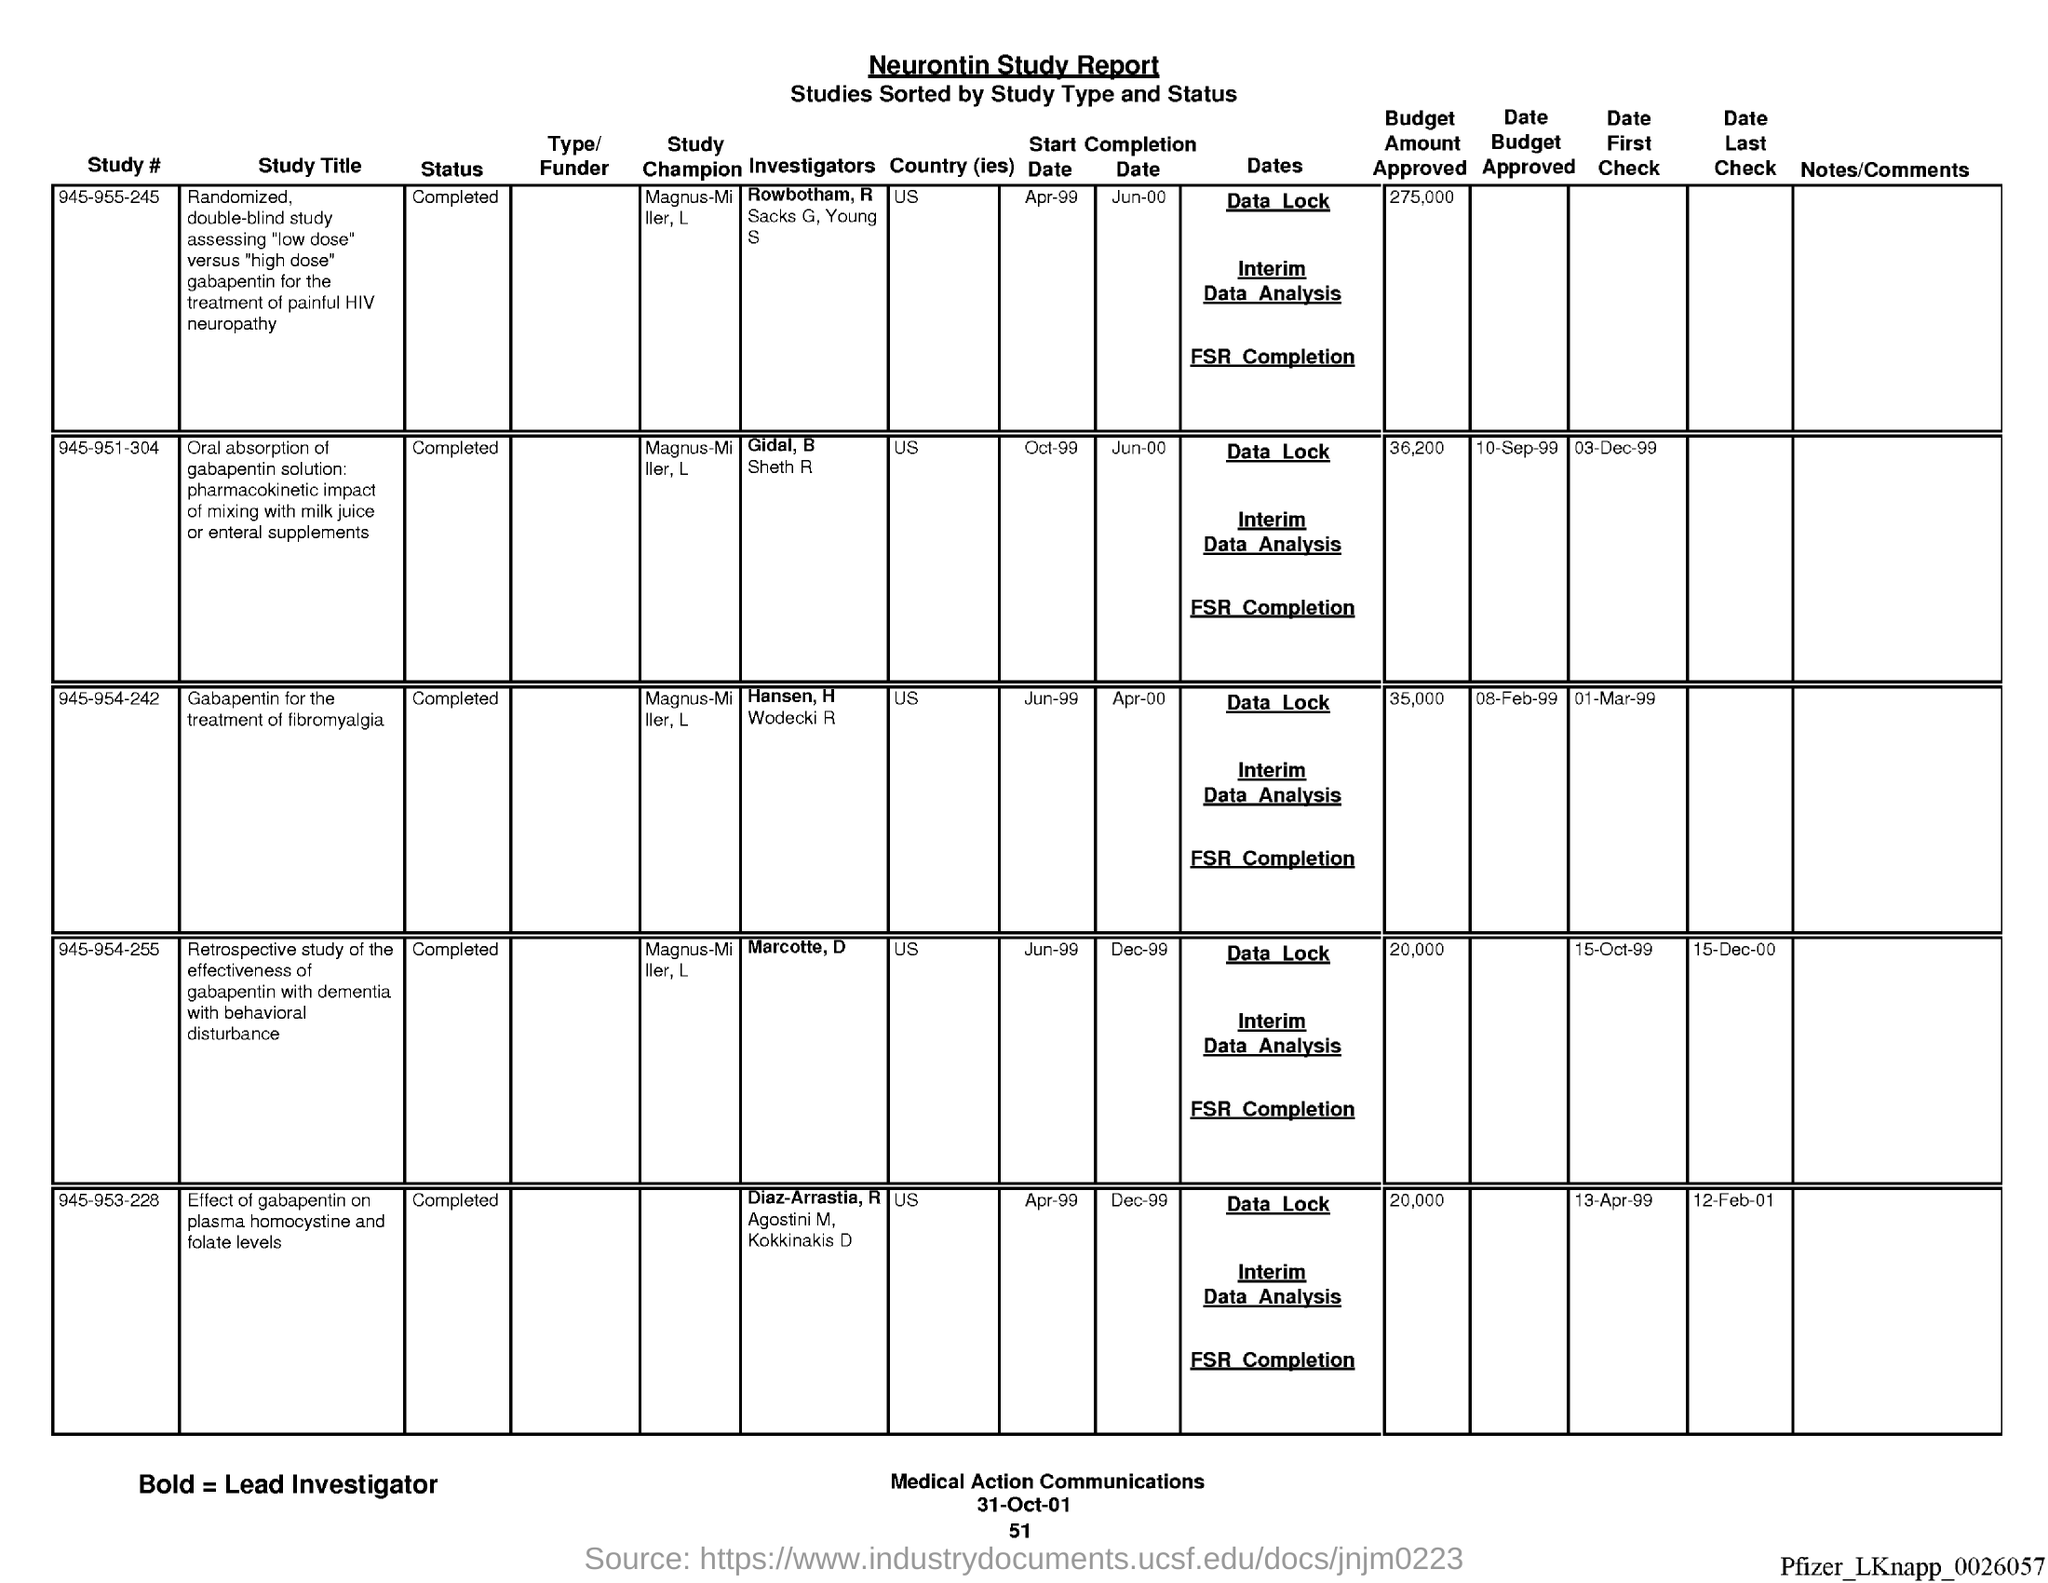What is the name of the report?
Make the answer very short. Neurontin study report. What is the date at bottom of the page?
Ensure brevity in your answer.  31-Oct-01. What is the page number below date?
Keep it short and to the point. 51. 